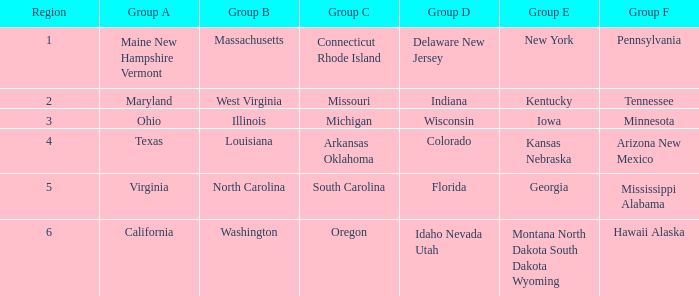What does the group b region combined with a group e region in georgia refer to? North Carolina. 